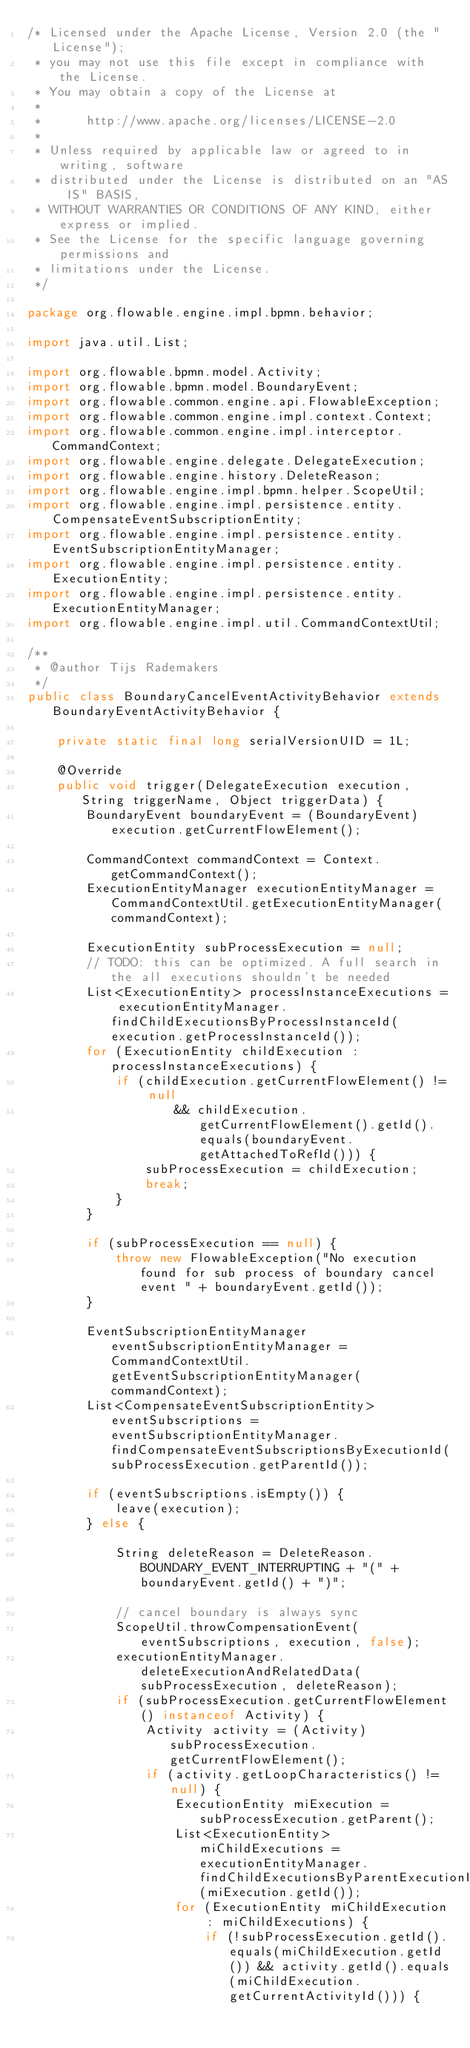Convert code to text. <code><loc_0><loc_0><loc_500><loc_500><_Java_>/* Licensed under the Apache License, Version 2.0 (the "License");
 * you may not use this file except in compliance with the License.
 * You may obtain a copy of the License at
 * 
 *      http://www.apache.org/licenses/LICENSE-2.0
 * 
 * Unless required by applicable law or agreed to in writing, software
 * distributed under the License is distributed on an "AS IS" BASIS,
 * WITHOUT WARRANTIES OR CONDITIONS OF ANY KIND, either express or implied.
 * See the License for the specific language governing permissions and
 * limitations under the License.
 */

package org.flowable.engine.impl.bpmn.behavior;

import java.util.List;

import org.flowable.bpmn.model.Activity;
import org.flowable.bpmn.model.BoundaryEvent;
import org.flowable.common.engine.api.FlowableException;
import org.flowable.common.engine.impl.context.Context;
import org.flowable.common.engine.impl.interceptor.CommandContext;
import org.flowable.engine.delegate.DelegateExecution;
import org.flowable.engine.history.DeleteReason;
import org.flowable.engine.impl.bpmn.helper.ScopeUtil;
import org.flowable.engine.impl.persistence.entity.CompensateEventSubscriptionEntity;
import org.flowable.engine.impl.persistence.entity.EventSubscriptionEntityManager;
import org.flowable.engine.impl.persistence.entity.ExecutionEntity;
import org.flowable.engine.impl.persistence.entity.ExecutionEntityManager;
import org.flowable.engine.impl.util.CommandContextUtil;

/**
 * @author Tijs Rademakers
 */
public class BoundaryCancelEventActivityBehavior extends BoundaryEventActivityBehavior {

    private static final long serialVersionUID = 1L;

    @Override
    public void trigger(DelegateExecution execution, String triggerName, Object triggerData) {
        BoundaryEvent boundaryEvent = (BoundaryEvent) execution.getCurrentFlowElement();

        CommandContext commandContext = Context.getCommandContext();
        ExecutionEntityManager executionEntityManager = CommandContextUtil.getExecutionEntityManager(commandContext);

        ExecutionEntity subProcessExecution = null;
        // TODO: this can be optimized. A full search in the all executions shouldn't be needed
        List<ExecutionEntity> processInstanceExecutions = executionEntityManager.findChildExecutionsByProcessInstanceId(execution.getProcessInstanceId());
        for (ExecutionEntity childExecution : processInstanceExecutions) {
            if (childExecution.getCurrentFlowElement() != null
                    && childExecution.getCurrentFlowElement().getId().equals(boundaryEvent.getAttachedToRefId())) {
                subProcessExecution = childExecution;
                break;
            }
        }

        if (subProcessExecution == null) {
            throw new FlowableException("No execution found for sub process of boundary cancel event " + boundaryEvent.getId());
        }

        EventSubscriptionEntityManager eventSubscriptionEntityManager = CommandContextUtil.getEventSubscriptionEntityManager(commandContext);
        List<CompensateEventSubscriptionEntity> eventSubscriptions = eventSubscriptionEntityManager.findCompensateEventSubscriptionsByExecutionId(subProcessExecution.getParentId());

        if (eventSubscriptions.isEmpty()) {
            leave(execution);
        } else {

            String deleteReason = DeleteReason.BOUNDARY_EVENT_INTERRUPTING + "(" + boundaryEvent.getId() + ")";

            // cancel boundary is always sync
            ScopeUtil.throwCompensationEvent(eventSubscriptions, execution, false);
            executionEntityManager.deleteExecutionAndRelatedData(subProcessExecution, deleteReason);
            if (subProcessExecution.getCurrentFlowElement() instanceof Activity) {
                Activity activity = (Activity) subProcessExecution.getCurrentFlowElement();
                if (activity.getLoopCharacteristics() != null) {
                    ExecutionEntity miExecution = subProcessExecution.getParent();
                    List<ExecutionEntity> miChildExecutions = executionEntityManager.findChildExecutionsByParentExecutionId(miExecution.getId());
                    for (ExecutionEntity miChildExecution : miChildExecutions) {
                        if (!subProcessExecution.getId().equals(miChildExecution.getId()) && activity.getId().equals(miChildExecution.getCurrentActivityId())) {</code> 